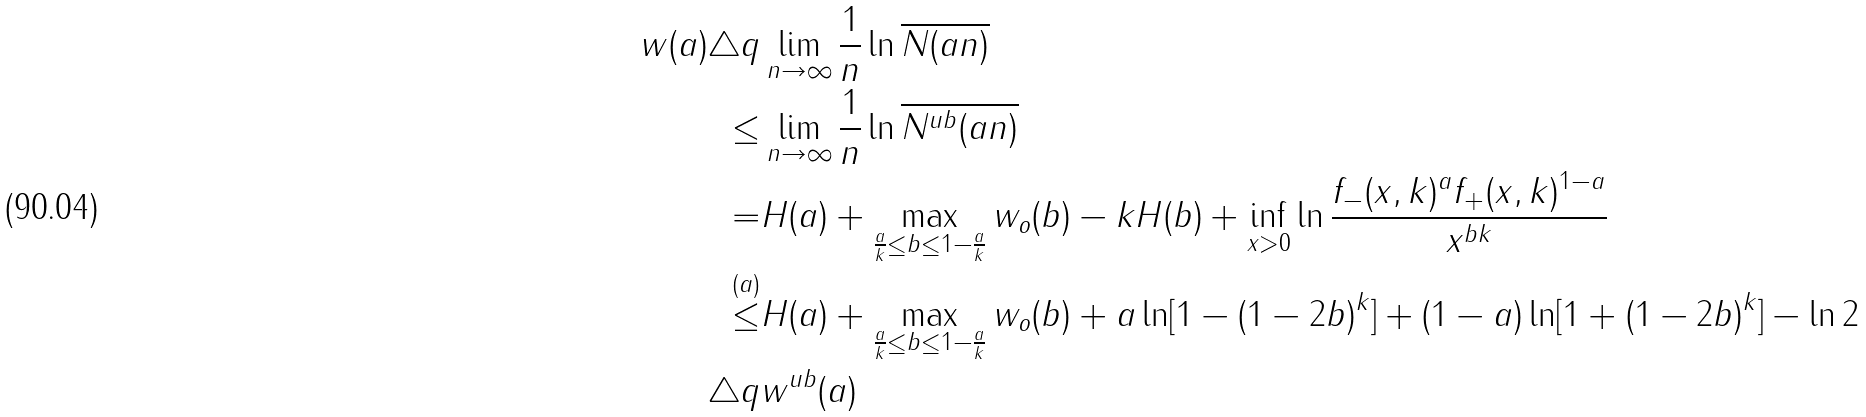<formula> <loc_0><loc_0><loc_500><loc_500>w ( a ) \triangle q & \lim _ { n \rightarrow \infty } \frac { 1 } { n } \ln \overline { N ( a n ) } \\ \leq & \lim _ { n \rightarrow \infty } \frac { 1 } { n } \ln \overline { N ^ { u b } ( a n ) } \\ = & H ( a ) + \max _ { \frac { a } { k } \leq b \leq 1 - \frac { a } { k } } w _ { o } ( b ) - k H ( b ) + \inf _ { x > 0 } \ln \frac { f _ { - } ( x , k ) ^ { a } f _ { + } ( x , k ) ^ { 1 - a } } { x ^ { b k } } \\ \stackrel { ( a ) } { \leq } & H ( a ) + \max _ { \frac { a } { k } \leq b \leq 1 - \frac { a } { k } } w _ { o } ( b ) + a \ln [ 1 - ( 1 - 2 b ) ^ { k } ] + ( 1 - a ) \ln [ 1 + ( 1 - 2 b ) ^ { k } ] - \ln 2 \\ \triangle q & w ^ { u b } ( a )</formula> 